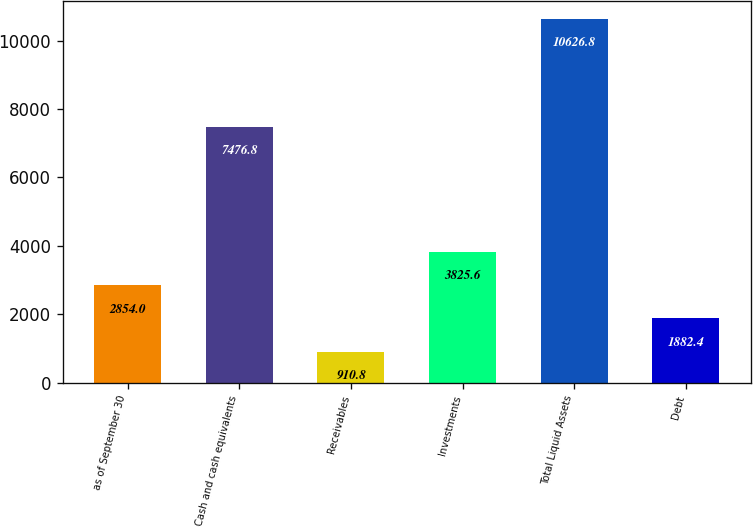<chart> <loc_0><loc_0><loc_500><loc_500><bar_chart><fcel>as of September 30<fcel>Cash and cash equivalents<fcel>Receivables<fcel>Investments<fcel>Total Liquid Assets<fcel>Debt<nl><fcel>2854<fcel>7476.8<fcel>910.8<fcel>3825.6<fcel>10626.8<fcel>1882.4<nl></chart> 